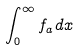<formula> <loc_0><loc_0><loc_500><loc_500>\int _ { 0 } ^ { \infty } f _ { a } d x</formula> 